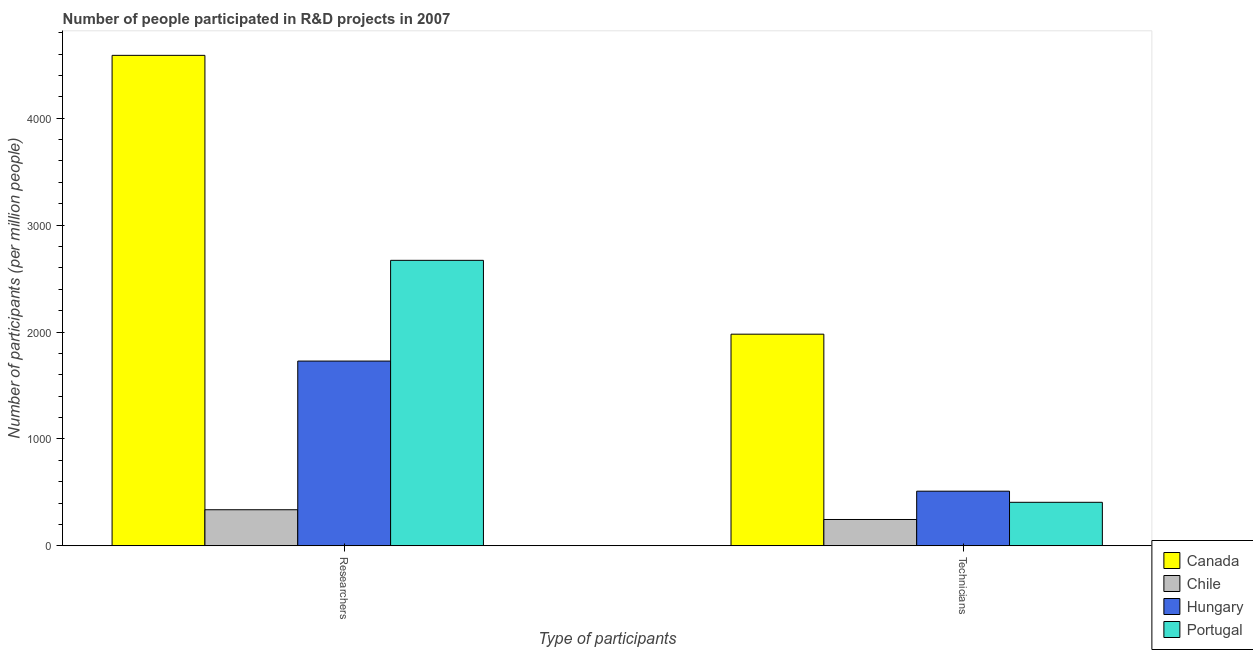How many groups of bars are there?
Your answer should be very brief. 2. Are the number of bars per tick equal to the number of legend labels?
Your answer should be compact. Yes. Are the number of bars on each tick of the X-axis equal?
Your answer should be compact. Yes. How many bars are there on the 1st tick from the right?
Ensure brevity in your answer.  4. What is the label of the 2nd group of bars from the left?
Keep it short and to the point. Technicians. What is the number of technicians in Chile?
Provide a succinct answer. 245.95. Across all countries, what is the maximum number of researchers?
Provide a short and direct response. 4588.22. Across all countries, what is the minimum number of technicians?
Your answer should be very brief. 245.95. In which country was the number of technicians minimum?
Keep it short and to the point. Chile. What is the total number of researchers in the graph?
Your response must be concise. 9323.95. What is the difference between the number of researchers in Hungary and that in Chile?
Provide a succinct answer. 1390.83. What is the difference between the number of technicians in Portugal and the number of researchers in Chile?
Offer a terse response. 69.62. What is the average number of technicians per country?
Your answer should be very brief. 785.78. What is the difference between the number of researchers and number of technicians in Portugal?
Provide a short and direct response. 2263.72. What is the ratio of the number of researchers in Hungary to that in Canada?
Offer a terse response. 0.38. Is the number of researchers in Portugal less than that in Canada?
Offer a terse response. Yes. How many bars are there?
Keep it short and to the point. 8. Are all the bars in the graph horizontal?
Offer a terse response. No. Does the graph contain any zero values?
Make the answer very short. No. Does the graph contain grids?
Your answer should be very brief. No. Where does the legend appear in the graph?
Ensure brevity in your answer.  Bottom right. How are the legend labels stacked?
Offer a terse response. Vertical. What is the title of the graph?
Your response must be concise. Number of people participated in R&D projects in 2007. What is the label or title of the X-axis?
Your answer should be very brief. Type of participants. What is the label or title of the Y-axis?
Your response must be concise. Number of participants (per million people). What is the Number of participants (per million people) of Canada in Researchers?
Provide a short and direct response. 4588.22. What is the Number of participants (per million people) of Chile in Researchers?
Make the answer very short. 337.18. What is the Number of participants (per million people) of Hungary in Researchers?
Ensure brevity in your answer.  1728.02. What is the Number of participants (per million people) of Portugal in Researchers?
Give a very brief answer. 2670.52. What is the Number of participants (per million people) in Canada in Technicians?
Provide a short and direct response. 1979.55. What is the Number of participants (per million people) in Chile in Technicians?
Make the answer very short. 245.95. What is the Number of participants (per million people) of Hungary in Technicians?
Offer a very short reply. 510.82. What is the Number of participants (per million people) of Portugal in Technicians?
Your answer should be very brief. 406.8. Across all Type of participants, what is the maximum Number of participants (per million people) of Canada?
Your answer should be compact. 4588.22. Across all Type of participants, what is the maximum Number of participants (per million people) of Chile?
Make the answer very short. 337.18. Across all Type of participants, what is the maximum Number of participants (per million people) of Hungary?
Your answer should be very brief. 1728.02. Across all Type of participants, what is the maximum Number of participants (per million people) in Portugal?
Your response must be concise. 2670.52. Across all Type of participants, what is the minimum Number of participants (per million people) of Canada?
Your answer should be compact. 1979.55. Across all Type of participants, what is the minimum Number of participants (per million people) of Chile?
Your answer should be very brief. 245.95. Across all Type of participants, what is the minimum Number of participants (per million people) in Hungary?
Offer a very short reply. 510.82. Across all Type of participants, what is the minimum Number of participants (per million people) in Portugal?
Keep it short and to the point. 406.8. What is the total Number of participants (per million people) in Canada in the graph?
Provide a short and direct response. 6567.77. What is the total Number of participants (per million people) in Chile in the graph?
Your answer should be very brief. 583.14. What is the total Number of participants (per million people) of Hungary in the graph?
Provide a succinct answer. 2238.84. What is the total Number of participants (per million people) in Portugal in the graph?
Offer a terse response. 3077.33. What is the difference between the Number of participants (per million people) of Canada in Researchers and that in Technicians?
Keep it short and to the point. 2608.67. What is the difference between the Number of participants (per million people) in Chile in Researchers and that in Technicians?
Ensure brevity in your answer.  91.23. What is the difference between the Number of participants (per million people) in Hungary in Researchers and that in Technicians?
Give a very brief answer. 1217.19. What is the difference between the Number of participants (per million people) in Portugal in Researchers and that in Technicians?
Offer a very short reply. 2263.72. What is the difference between the Number of participants (per million people) in Canada in Researchers and the Number of participants (per million people) in Chile in Technicians?
Give a very brief answer. 4342.27. What is the difference between the Number of participants (per million people) in Canada in Researchers and the Number of participants (per million people) in Hungary in Technicians?
Your answer should be very brief. 4077.4. What is the difference between the Number of participants (per million people) of Canada in Researchers and the Number of participants (per million people) of Portugal in Technicians?
Your answer should be compact. 4181.42. What is the difference between the Number of participants (per million people) of Chile in Researchers and the Number of participants (per million people) of Hungary in Technicians?
Make the answer very short. -173.64. What is the difference between the Number of participants (per million people) of Chile in Researchers and the Number of participants (per million people) of Portugal in Technicians?
Offer a very short reply. -69.62. What is the difference between the Number of participants (per million people) of Hungary in Researchers and the Number of participants (per million people) of Portugal in Technicians?
Your answer should be compact. 1321.22. What is the average Number of participants (per million people) in Canada per Type of participants?
Provide a short and direct response. 3283.89. What is the average Number of participants (per million people) in Chile per Type of participants?
Keep it short and to the point. 291.57. What is the average Number of participants (per million people) in Hungary per Type of participants?
Your answer should be compact. 1119.42. What is the average Number of participants (per million people) of Portugal per Type of participants?
Make the answer very short. 1538.66. What is the difference between the Number of participants (per million people) in Canada and Number of participants (per million people) in Chile in Researchers?
Provide a succinct answer. 4251.04. What is the difference between the Number of participants (per million people) in Canada and Number of participants (per million people) in Hungary in Researchers?
Offer a very short reply. 2860.21. What is the difference between the Number of participants (per million people) of Canada and Number of participants (per million people) of Portugal in Researchers?
Your answer should be compact. 1917.7. What is the difference between the Number of participants (per million people) of Chile and Number of participants (per million people) of Hungary in Researchers?
Your answer should be very brief. -1390.83. What is the difference between the Number of participants (per million people) in Chile and Number of participants (per million people) in Portugal in Researchers?
Your answer should be very brief. -2333.34. What is the difference between the Number of participants (per million people) of Hungary and Number of participants (per million people) of Portugal in Researchers?
Your answer should be compact. -942.51. What is the difference between the Number of participants (per million people) in Canada and Number of participants (per million people) in Chile in Technicians?
Keep it short and to the point. 1733.6. What is the difference between the Number of participants (per million people) of Canada and Number of participants (per million people) of Hungary in Technicians?
Offer a very short reply. 1468.72. What is the difference between the Number of participants (per million people) of Canada and Number of participants (per million people) of Portugal in Technicians?
Offer a terse response. 1572.75. What is the difference between the Number of participants (per million people) of Chile and Number of participants (per million people) of Hungary in Technicians?
Provide a short and direct response. -264.87. What is the difference between the Number of participants (per million people) in Chile and Number of participants (per million people) in Portugal in Technicians?
Your answer should be compact. -160.85. What is the difference between the Number of participants (per million people) in Hungary and Number of participants (per million people) in Portugal in Technicians?
Your answer should be compact. 104.02. What is the ratio of the Number of participants (per million people) of Canada in Researchers to that in Technicians?
Offer a very short reply. 2.32. What is the ratio of the Number of participants (per million people) of Chile in Researchers to that in Technicians?
Provide a short and direct response. 1.37. What is the ratio of the Number of participants (per million people) of Hungary in Researchers to that in Technicians?
Give a very brief answer. 3.38. What is the ratio of the Number of participants (per million people) of Portugal in Researchers to that in Technicians?
Ensure brevity in your answer.  6.56. What is the difference between the highest and the second highest Number of participants (per million people) of Canada?
Provide a short and direct response. 2608.67. What is the difference between the highest and the second highest Number of participants (per million people) of Chile?
Ensure brevity in your answer.  91.23. What is the difference between the highest and the second highest Number of participants (per million people) in Hungary?
Offer a very short reply. 1217.19. What is the difference between the highest and the second highest Number of participants (per million people) in Portugal?
Offer a very short reply. 2263.72. What is the difference between the highest and the lowest Number of participants (per million people) in Canada?
Provide a short and direct response. 2608.67. What is the difference between the highest and the lowest Number of participants (per million people) in Chile?
Your answer should be compact. 91.23. What is the difference between the highest and the lowest Number of participants (per million people) in Hungary?
Offer a very short reply. 1217.19. What is the difference between the highest and the lowest Number of participants (per million people) of Portugal?
Your response must be concise. 2263.72. 